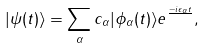<formula> <loc_0><loc_0><loc_500><loc_500>| \psi ( t ) \rangle = \sum _ { \alpha } c _ { \alpha } | \phi _ { \alpha } ( t ) \rangle e ^ { \frac { - i \epsilon _ { \alpha } t } { } } ,</formula> 